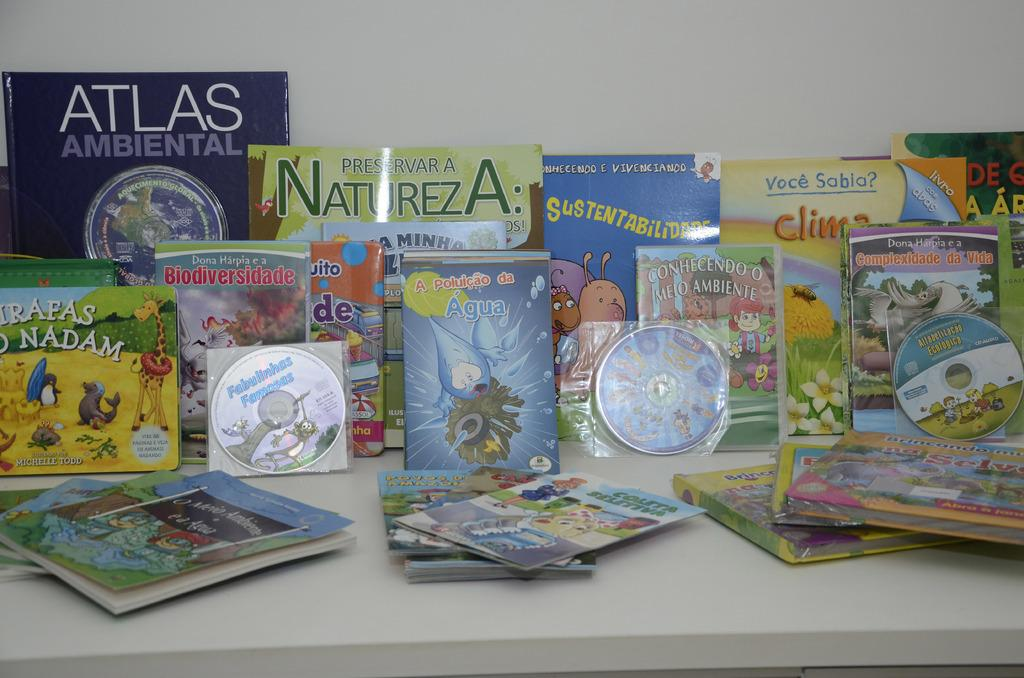<image>
Give a short and clear explanation of the subsequent image. An Atlas leaning against the wall behind other books. 